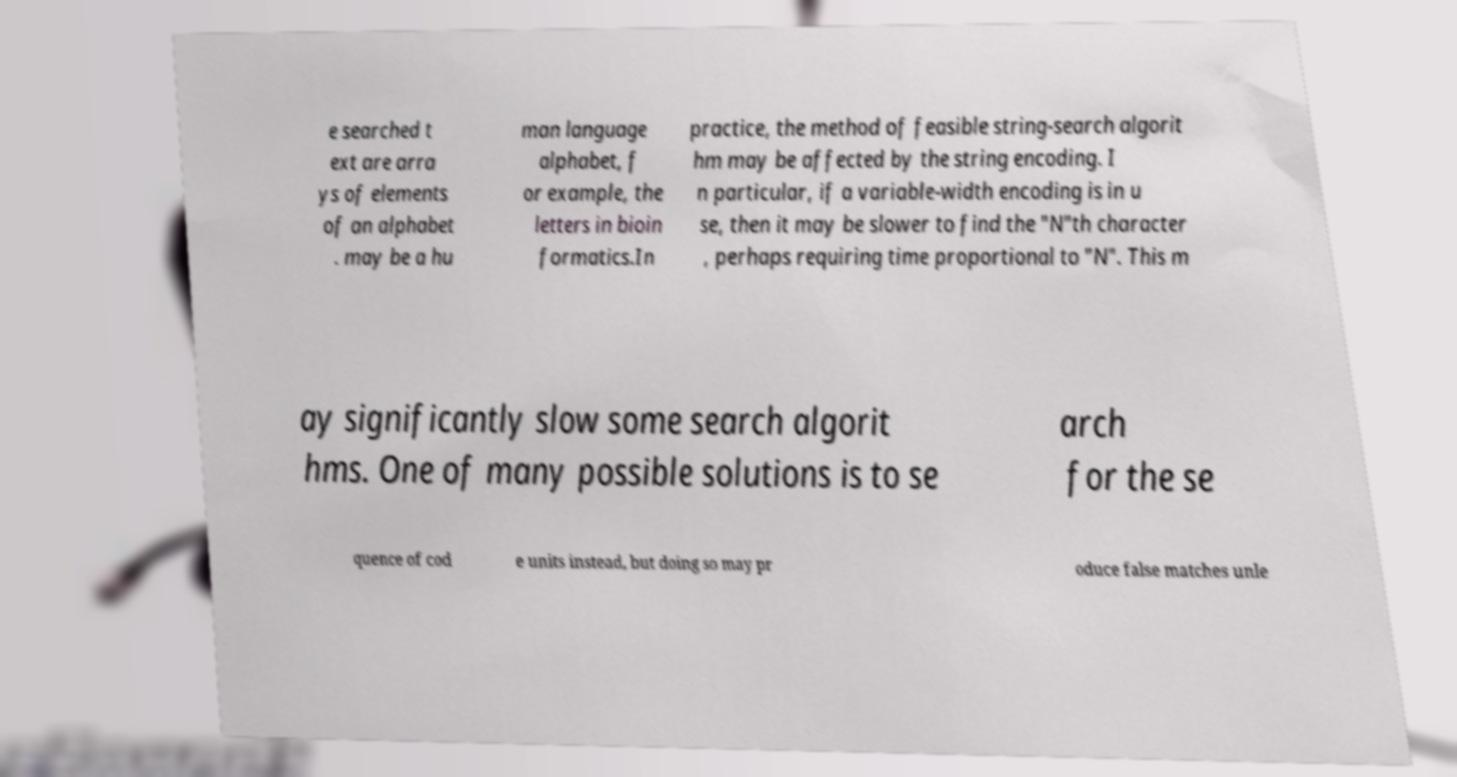What messages or text are displayed in this image? I need them in a readable, typed format. e searched t ext are arra ys of elements of an alphabet . may be a hu man language alphabet, f or example, the letters in bioin formatics.In practice, the method of feasible string-search algorit hm may be affected by the string encoding. I n particular, if a variable-width encoding is in u se, then it may be slower to find the "N"th character , perhaps requiring time proportional to "N". This m ay significantly slow some search algorit hms. One of many possible solutions is to se arch for the se quence of cod e units instead, but doing so may pr oduce false matches unle 